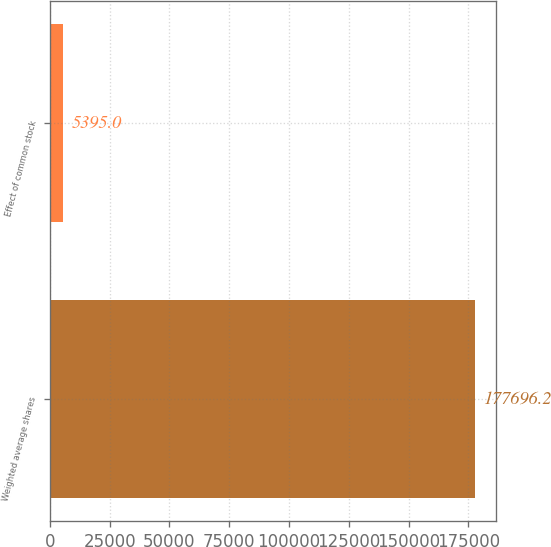<chart> <loc_0><loc_0><loc_500><loc_500><bar_chart><fcel>Weighted average shares<fcel>Effect of common stock<nl><fcel>177696<fcel>5395<nl></chart> 